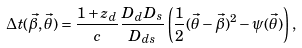<formula> <loc_0><loc_0><loc_500><loc_500>\Delta t ( \vec { \beta } , \vec { \theta } ) = \frac { 1 + z _ { d } } { c } \frac { D _ { d } D _ { s } } { D _ { d s } } \left ( \frac { 1 } { 2 } ( \vec { \theta } - \vec { \beta } ) ^ { 2 } - \psi ( \vec { \theta } ) \right ) ,</formula> 